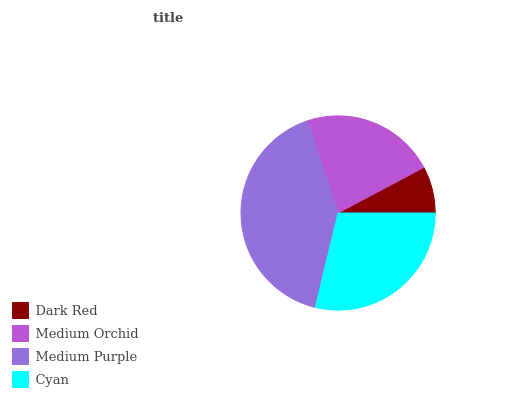Is Dark Red the minimum?
Answer yes or no. Yes. Is Medium Purple the maximum?
Answer yes or no. Yes. Is Medium Orchid the minimum?
Answer yes or no. No. Is Medium Orchid the maximum?
Answer yes or no. No. Is Medium Orchid greater than Dark Red?
Answer yes or no. Yes. Is Dark Red less than Medium Orchid?
Answer yes or no. Yes. Is Dark Red greater than Medium Orchid?
Answer yes or no. No. Is Medium Orchid less than Dark Red?
Answer yes or no. No. Is Cyan the high median?
Answer yes or no. Yes. Is Medium Orchid the low median?
Answer yes or no. Yes. Is Medium Orchid the high median?
Answer yes or no. No. Is Cyan the low median?
Answer yes or no. No. 